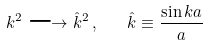Convert formula to latex. <formula><loc_0><loc_0><loc_500><loc_500>k ^ { 2 } \longrightarrow { \hat { k } } ^ { 2 } \, , \quad \hat { k } \equiv \frac { \sin k a } a</formula> 